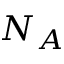Convert formula to latex. <formula><loc_0><loc_0><loc_500><loc_500>N _ { A }</formula> 